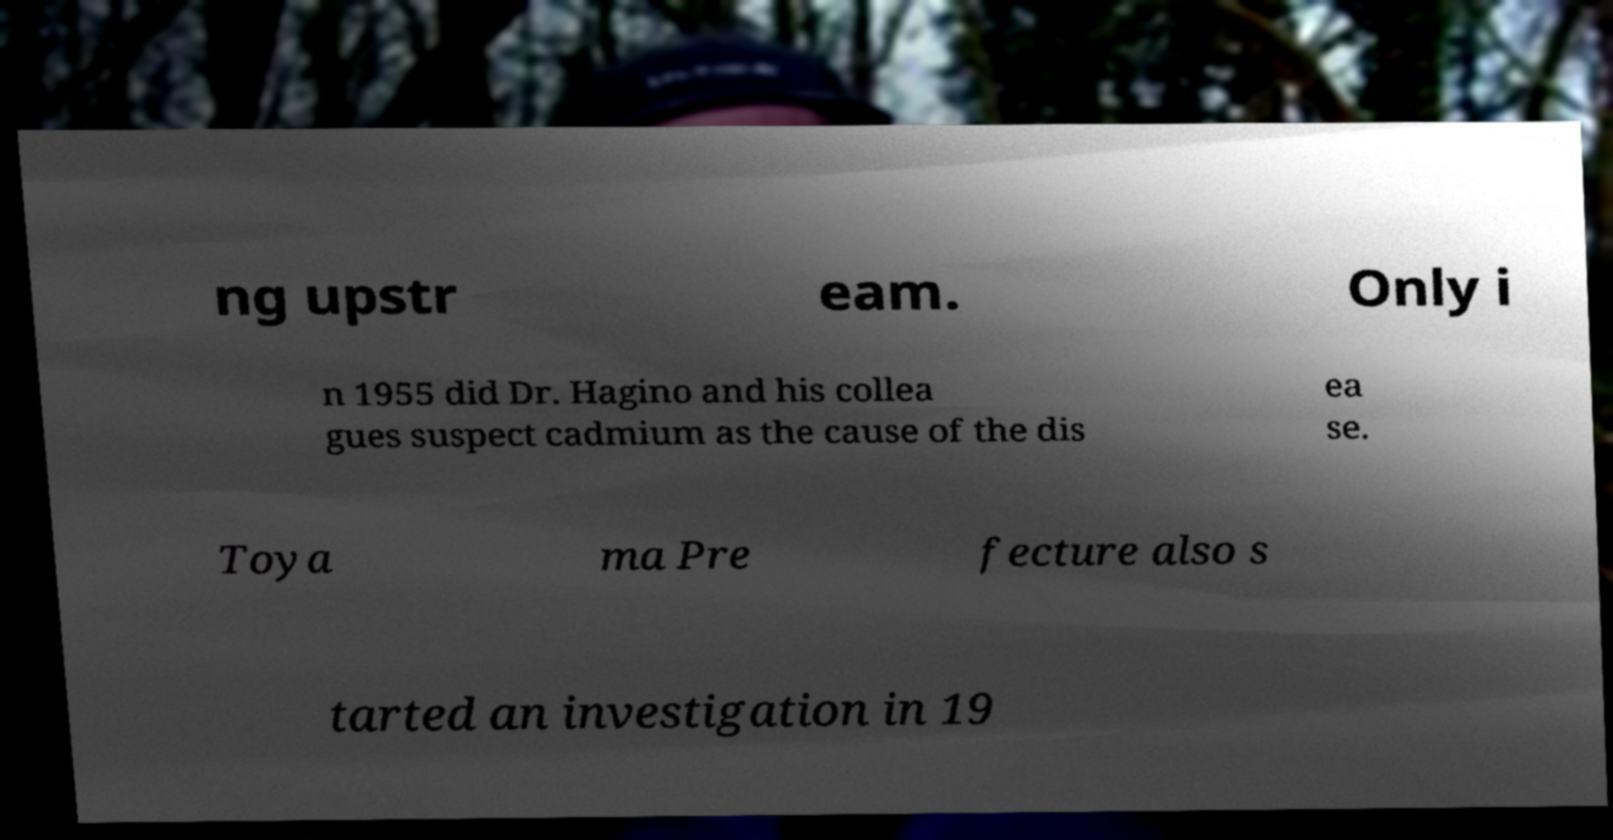For documentation purposes, I need the text within this image transcribed. Could you provide that? ng upstr eam. Only i n 1955 did Dr. Hagino and his collea gues suspect cadmium as the cause of the dis ea se. Toya ma Pre fecture also s tarted an investigation in 19 